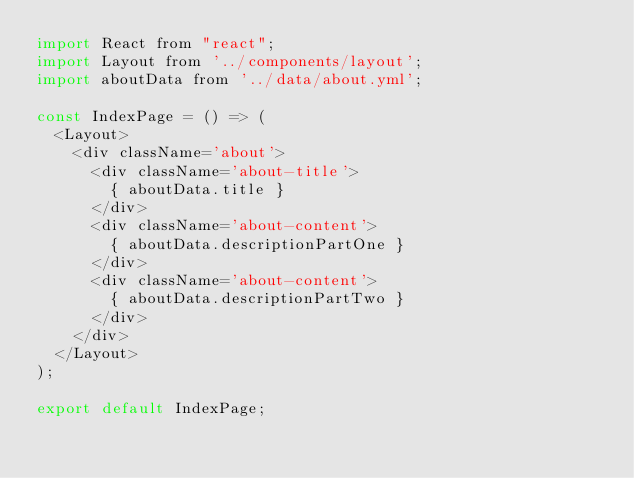Convert code to text. <code><loc_0><loc_0><loc_500><loc_500><_JavaScript_>import React from "react";
import Layout from '../components/layout';
import aboutData from '../data/about.yml';

const IndexPage = () => (
  <Layout>
    <div className='about'>
      <div className='about-title'>
        { aboutData.title }
      </div>
      <div className='about-content'>
        { aboutData.descriptionPartOne }
      </div>
      <div className='about-content'>
        { aboutData.descriptionPartTwo }
      </div>
    </div>
  </Layout>
);

export default IndexPage;
</code> 